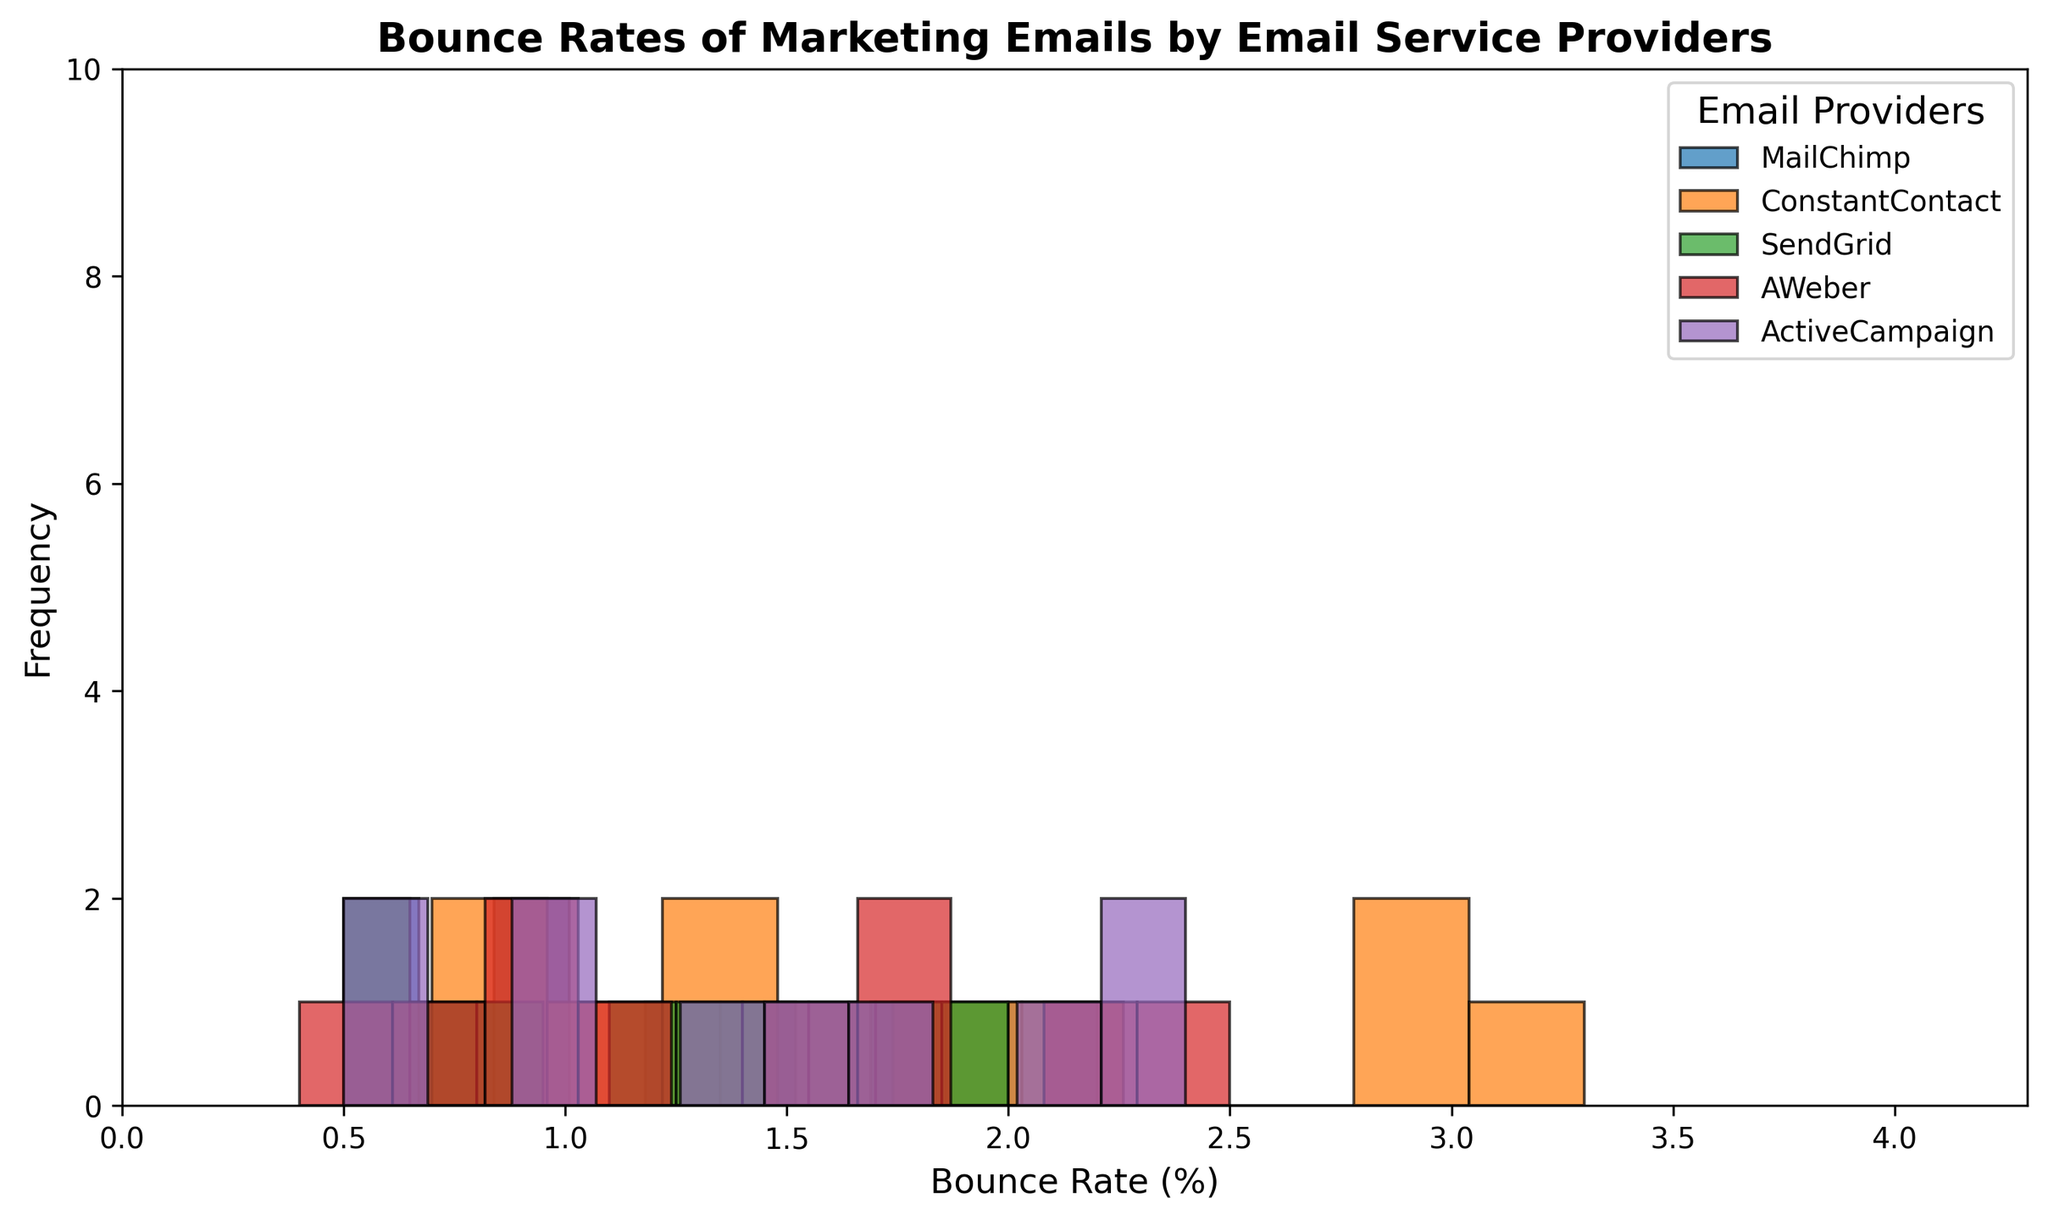Which email service provider shows the most frequent occurrences of the highest bounce rates? Looking at the histogram, the data series with the highest bounce rates (around 3.0%) and the most bars clustered at the higher end of the bounce rate range belongs to ConstantContact.
Answer: ConstantContact Which email service provider has the lowest bounce rate occurrences predominantly between 0.5% and 1.0%? By observing the colors and the distribution of the bars within the range of 0.5% to 1.0%, SendGrid's green bars appear most frequently in this range.
Answer: SendGrid How many email providers have occurrences of bounce rates above 2.5%? Examining the histograms' rightmost bins that reflect the range above 2.5%, two email providers (ConstantContact and ActiveCampaign) show bounce rates above 2.5%.
Answer: Two Which email service provider has the highest peak (most occurrences at the same bounce rate value)? Examining the height of the bars, ConstantContact has the highest peak with the most occurrences at the bounce rate of around 3.0%.
Answer: ConstantContact What is the range of bounce rates that MailChimp has their most occurrences? By visually assessing the concentration and the height of the blue bars, MailChimp’s peak frequency appears between 0.5% and 2.2%.
Answer: 0.5% to 2.2% What’s the visual difference in the number of occurrences between the lowest and highest bounce rates for AWeber? For AWeber, the red bars are spread fairly evenly without any extremely tall peaks at the lowest or highest ranges. The bounce rates are more evenly distributed between 0.4% and 2.5%.
Answer: Evenly distributed What email provider has the least frequent occurrence of bounce rates above 2.0%? Observing the bars' height above 2.0%, SendGrid has the least occurrences.
Answer: SendGrid Which email provider has most of its bounce rates clustered in the middle range between 1.0% and 2.0%? Looking at the figures, ActiveCampaign's purple bars are most concentrated in the middle range between 1.0% and 2.0%.
Answer: ActiveCampaign Which two email service providers show a similar distribution of bounce rates? By examining the histogram's general shapes and color patterns, both MailChimp and AWeber show similar distributions, with no extreme peaks and fairly balanced bounce rates.
Answer: MailChimp and AWeber 